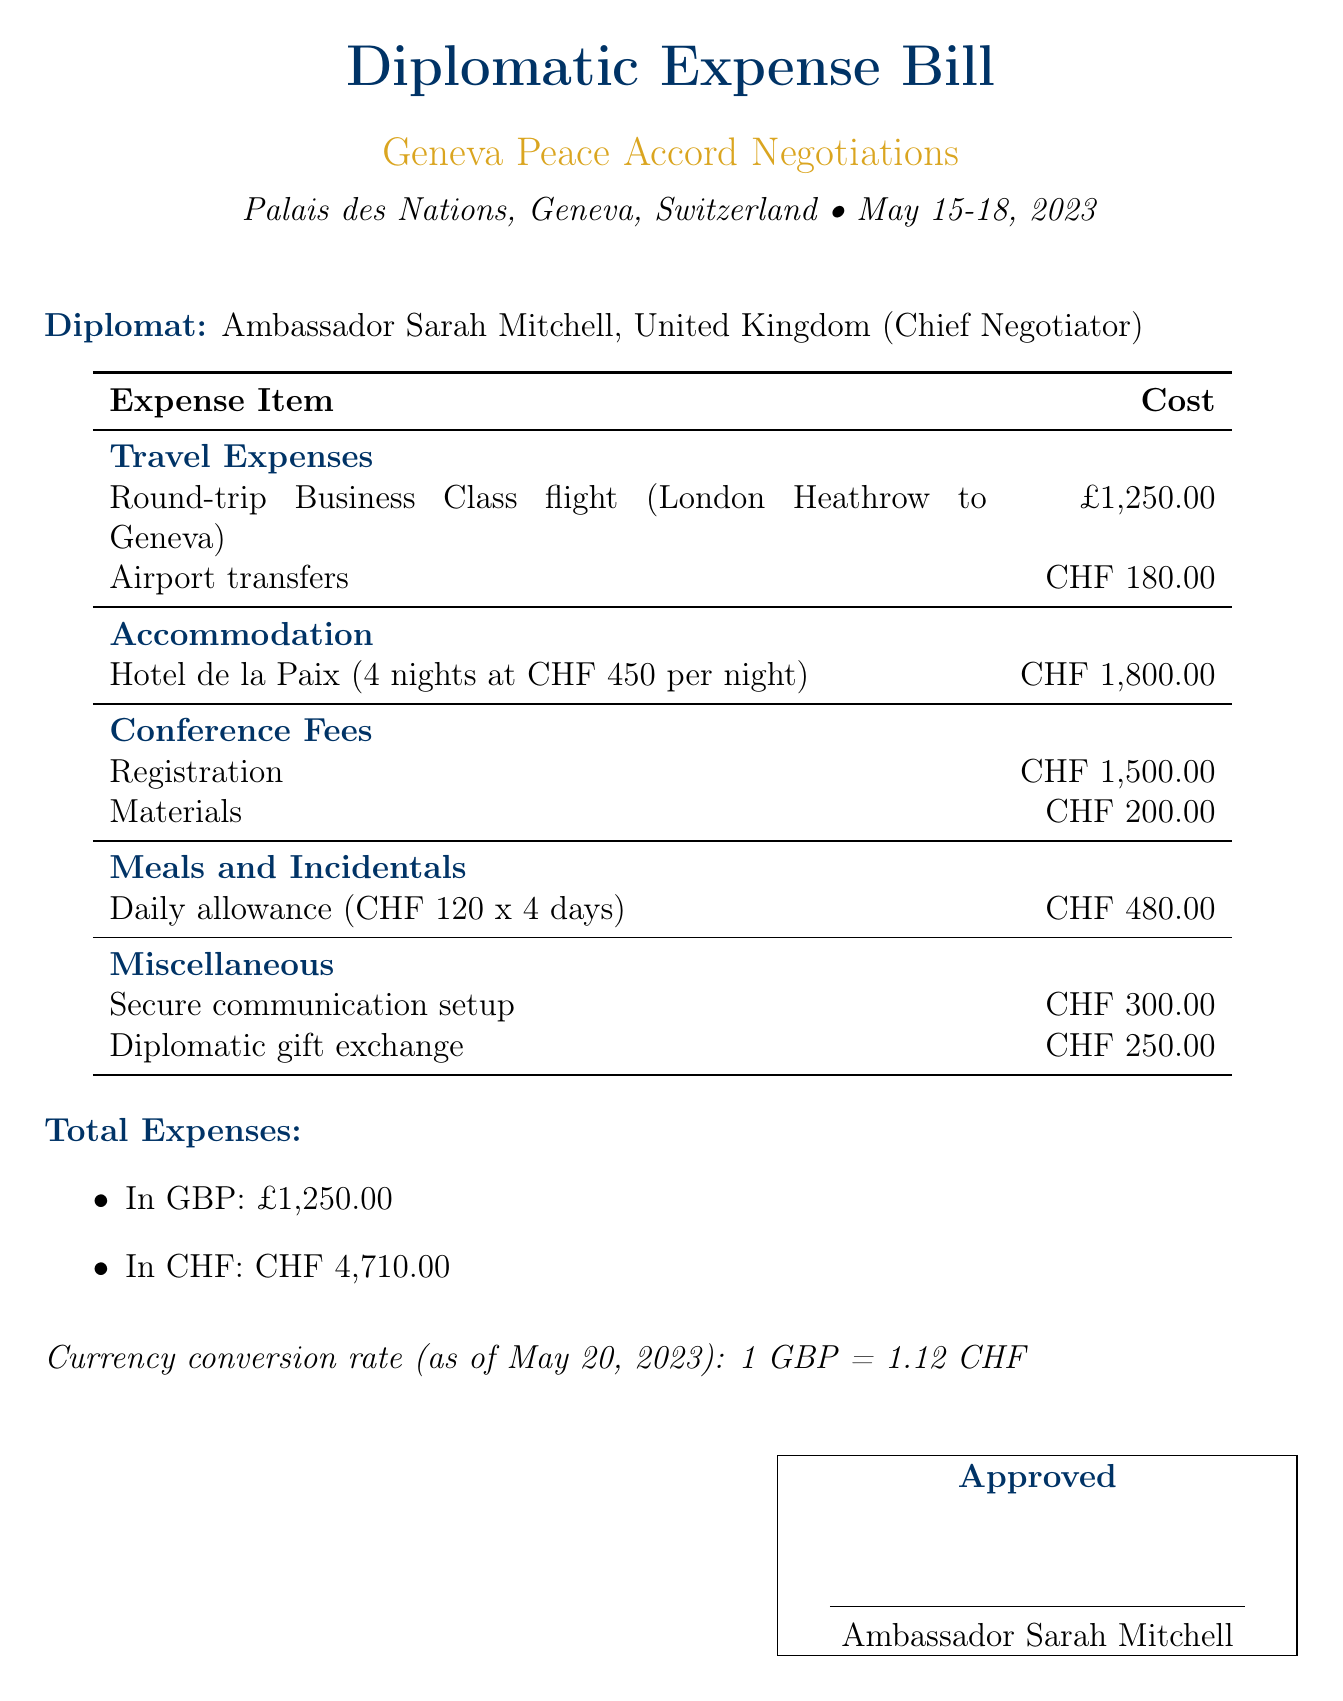What is the name of the Chief Negotiator? The Chief Negotiator is the diplomat responsible for leading the negotiations, which is stated as Ambassador Sarah Mitchell, United Kingdom.
Answer: Ambassador Sarah Mitchell What is the total cost of accommodation? The document specifies accommodation costs as CHF 1,800.00 for 4 nights at CHF 450 per night.
Answer: CHF 1,800.00 What is the currency conversion rate mentioned in the document? The currency conversion rate is provided in the document as of May 20, 2023, relating GBP to CHF.
Answer: 1 GBP = 1.12 CHF How many days was the daily allowance calculated for? The daily allowance is specified as being for 4 days, as indicated by CHF 120 multiplied by 4 days.
Answer: 4 days What was the cost of the registration for the conference? The registration fee for the conference is detailed in the document, showing the cost clearly.
Answer: CHF 1,500.00 What is the total expense in GBP? The total expenses in GBP are highlighted at the very end of the document, summarizing all costs.
Answer: £1,250.00 What item was listed under miscellaneous expenses? The document contains specific entries under miscellaneous expenses, requiring identification of any listed item.
Answer: Secure communication setup How many nights did the diplomat stay in the hotel? The hotel accommodation cost is broken down into a per night amount and the total number of nights, informing this count.
Answer: 4 nights 